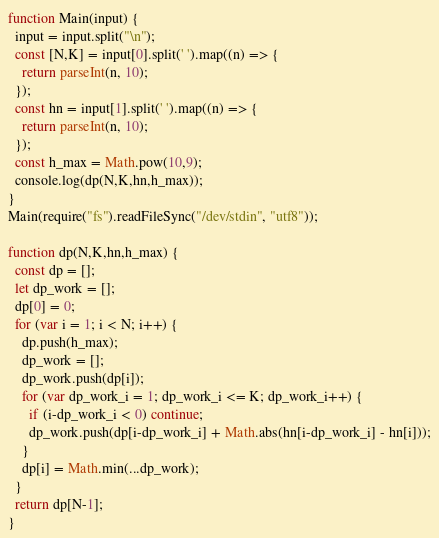<code> <loc_0><loc_0><loc_500><loc_500><_JavaScript_>function Main(input) {
  input = input.split("\n");
  const [N,K] = input[0].split(' ').map((n) => {
    return parseInt(n, 10);
  });
  const hn = input[1].split(' ').map((n) => {
    return parseInt(n, 10);
  });
  const h_max = Math.pow(10,9);
  console.log(dp(N,K,hn,h_max));
}
Main(require("fs").readFileSync("/dev/stdin", "utf8"));

function dp(N,K,hn,h_max) {
  const dp = [];
  let dp_work = [];
  dp[0] = 0;
  for (var i = 1; i < N; i++) {
    dp.push(h_max);
    dp_work = [];
    dp_work.push(dp[i]);
    for (var dp_work_i = 1; dp_work_i <= K; dp_work_i++) {
      if (i-dp_work_i < 0) continue;
      dp_work.push(dp[i-dp_work_i] + Math.abs(hn[i-dp_work_i] - hn[i]));
    }
    dp[i] = Math.min(...dp_work);
  }
  return dp[N-1];
}
</code> 